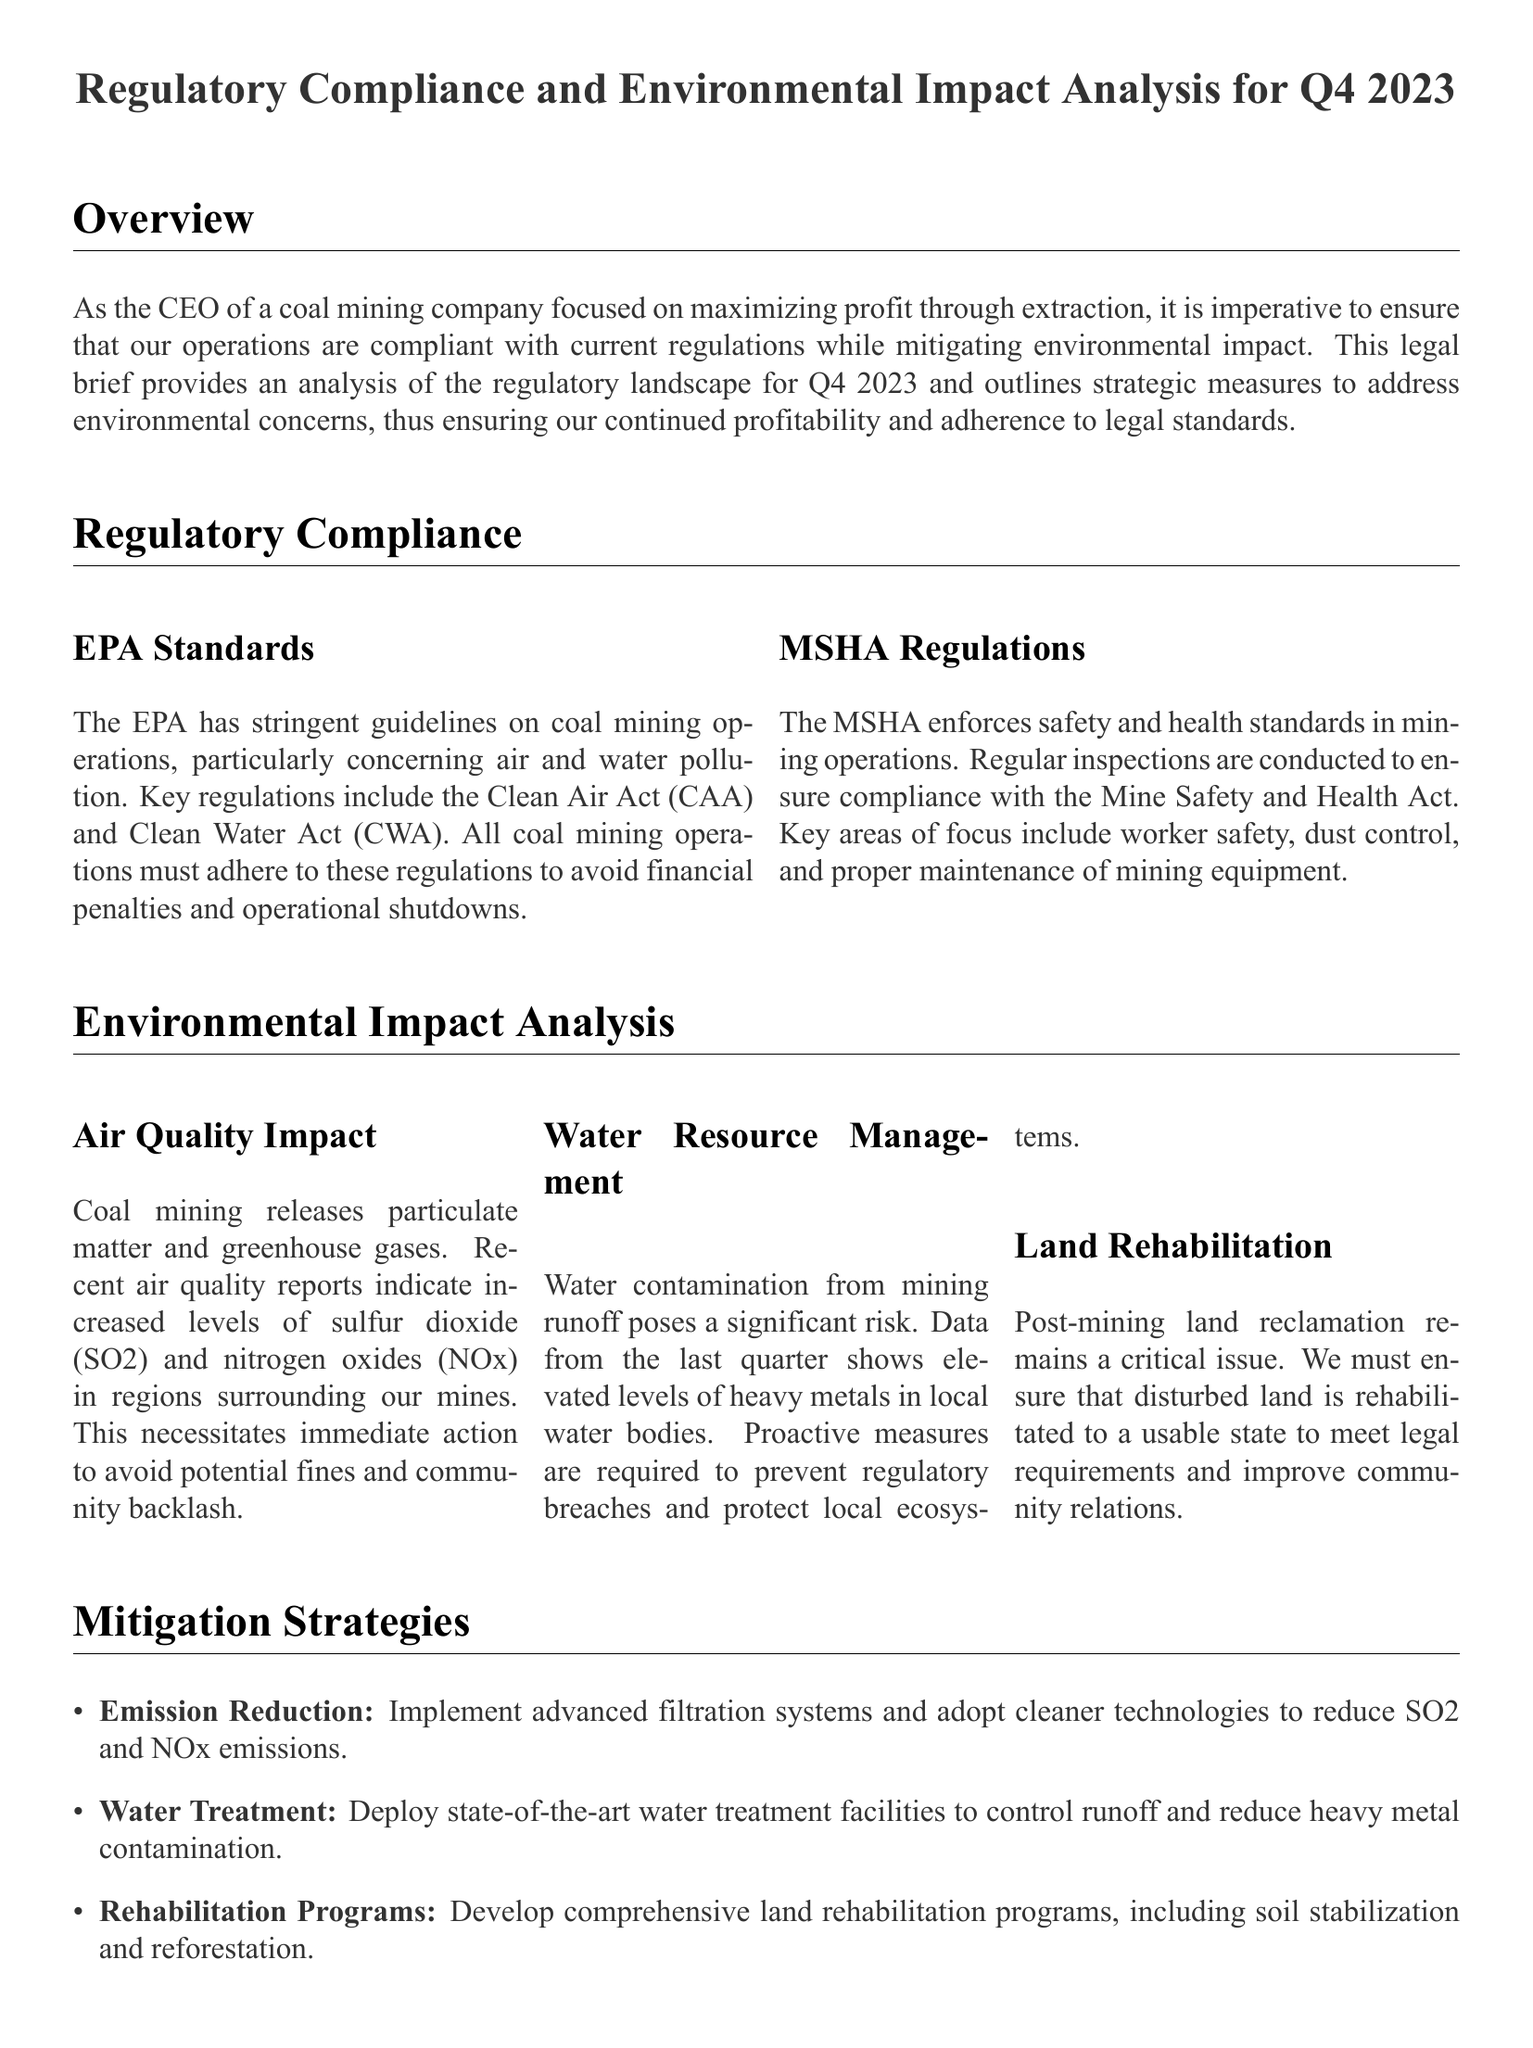What are the key regulations that coal mining operations must adhere to? The key regulations include the Clean Air Act (CAA) and Clean Water Act (CWA).
Answer: Clean Air Act and Clean Water Act What is the focus of MSHA regulations? The focus includes worker safety, dust control, and proper maintenance of mining equipment.
Answer: Worker safety, dust control, and equipment maintenance What elevated levels are reported in water bodies? Elevated levels of heavy metals are reported in local water bodies.
Answer: Heavy metals What are the three main areas of environmental impact analyzed? The areas are air quality impact, water resource management, and land rehabilitation.
Answer: Air quality impact, water resource management, land rehabilitation What is one mitigation strategy for emission reduction? One strategy is to implement advanced filtration systems and adopt cleaner technologies.
Answer: Advanced filtration systems How does the document propose to handle water contamination? The document proposes deploying state-of-the-art water treatment facilities to control runoff and reduce heavy metal contamination.
Answer: Deploy water treatment facilities What is the purpose of post-mining land reclamation? The purpose is to ensure that disturbed land is rehabilitated to a usable state.
Answer: To rehabilitate disturbed land What is the importance of addressing regulatory compliance according to the document? Addressing compliance helps sustain operations and profitability.
Answer: Sustain operations and profitability 